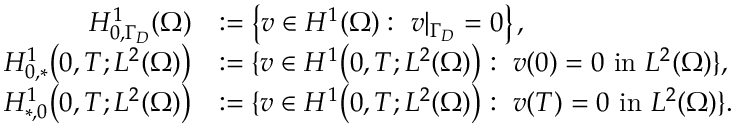Convert formula to latex. <formula><loc_0><loc_0><loc_500><loc_500>\begin{array} { r l } { H _ { 0 , \Gamma _ { D } } ^ { 1 } ( \Omega ) } & { \colon = \left \{ v \in H ^ { 1 } ( \Omega ) \colon \ v | _ { \Gamma _ { D } } = 0 \right \} , } \\ { H _ { 0 , * } ^ { 1 } \left ( 0 , T ; L ^ { 2 } ( \Omega ) \right ) } & { \colon = \{ v \in H ^ { 1 } \left ( 0 , T ; L ^ { 2 } ( \Omega ) \right ) \colon \ v ( 0 ) = 0 \ i n \ L ^ { 2 } ( \Omega ) \} , } \\ { H _ { * , 0 } ^ { 1 } \left ( 0 , T ; L ^ { 2 } ( \Omega ) \right ) } & { \colon = \{ v \in H ^ { 1 } \left ( 0 , T ; L ^ { 2 } ( \Omega ) \right ) \colon \ v ( T ) = 0 \ i n \ L ^ { 2 } ( \Omega ) \} . } \end{array}</formula> 